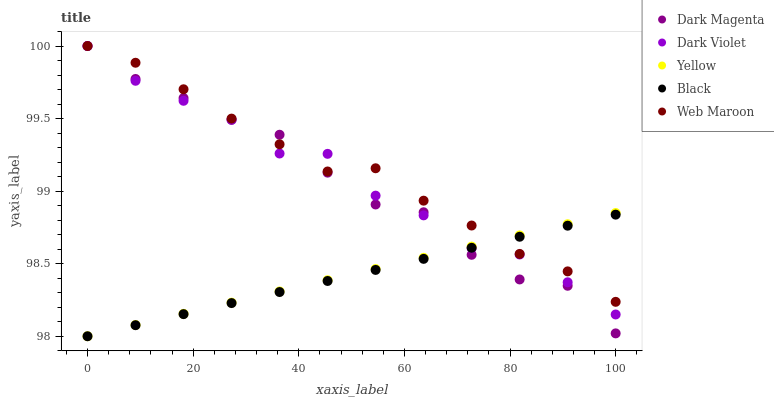Does Black have the minimum area under the curve?
Answer yes or no. Yes. Does Web Maroon have the maximum area under the curve?
Answer yes or no. Yes. Does Yellow have the minimum area under the curve?
Answer yes or no. No. Does Yellow have the maximum area under the curve?
Answer yes or no. No. Is Yellow the smoothest?
Answer yes or no. Yes. Is Dark Violet the roughest?
Answer yes or no. Yes. Is Black the smoothest?
Answer yes or no. No. Is Black the roughest?
Answer yes or no. No. Does Black have the lowest value?
Answer yes or no. Yes. Does Dark Magenta have the lowest value?
Answer yes or no. No. Does Dark Violet have the highest value?
Answer yes or no. Yes. Does Yellow have the highest value?
Answer yes or no. No. Does Yellow intersect Black?
Answer yes or no. Yes. Is Yellow less than Black?
Answer yes or no. No. Is Yellow greater than Black?
Answer yes or no. No. 